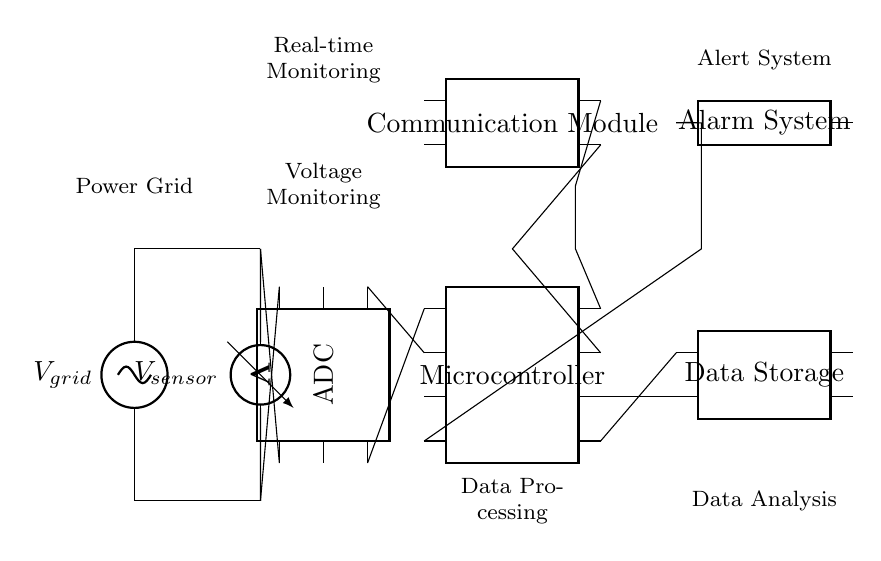What is the main power input for the circuit? The main power input for the circuit is represented by the voltage source labeled V_grid. It is the source that powers the entire circuit.
Answer: V_grid What component is used to measure the voltage from the grid? The voltage from the grid is measured using a voltmeter component, which is located directly in line with the V_grid and connected to both the upper and lower parts of the circuit.
Answer: Voltmeter How many pins does the microcontroller have? The microcontroller has eight pins, as indicated by the dipchip symbol showing the number of pins next to it.
Answer: Eight What is the purpose of the analog-to-digital converter in this circuit? The purpose of the analog-to-digital converter (ADC) is to convert the analog voltage readings from the voltmeter into digital signals that can be processed by the microcontroller for further analysis.
Answer: Conversion What system is activated when certain conditions are detected in the circuit? The alarm system is activated based on the conditions monitored by the microcontroller, which indicates that it will trigger alerts when specific thresholds are met.
Answer: Alarm system How is data transferred from the microcontroller to other components? Data is transferred from the microcontroller to other components through connected pins that link to data storage and the communication module, allowing real-time data sharing and processing.
Answer: Connected pins 